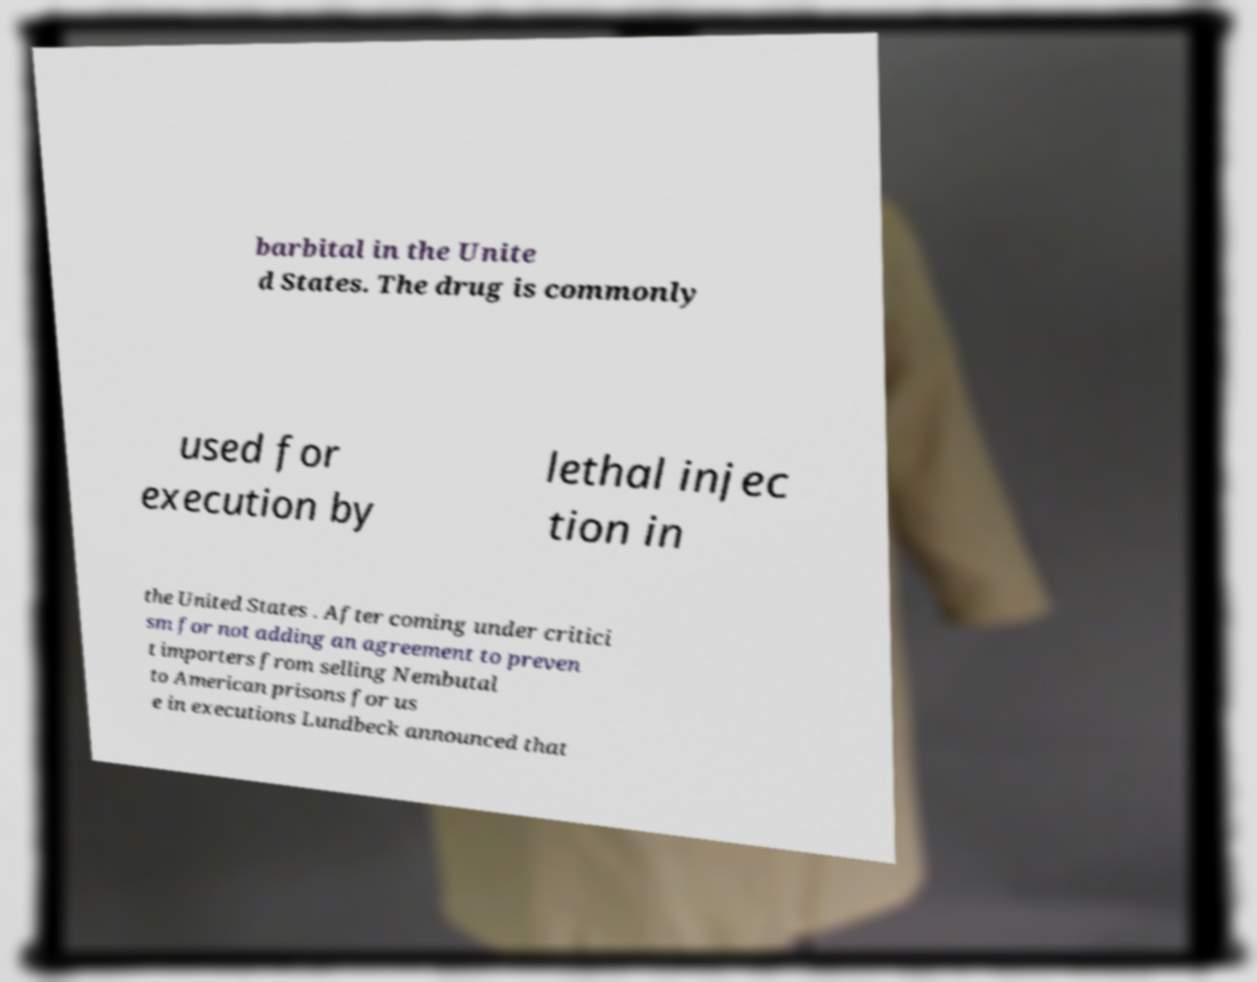Please read and relay the text visible in this image. What does it say? barbital in the Unite d States. The drug is commonly used for execution by lethal injec tion in the United States . After coming under critici sm for not adding an agreement to preven t importers from selling Nembutal to American prisons for us e in executions Lundbeck announced that 